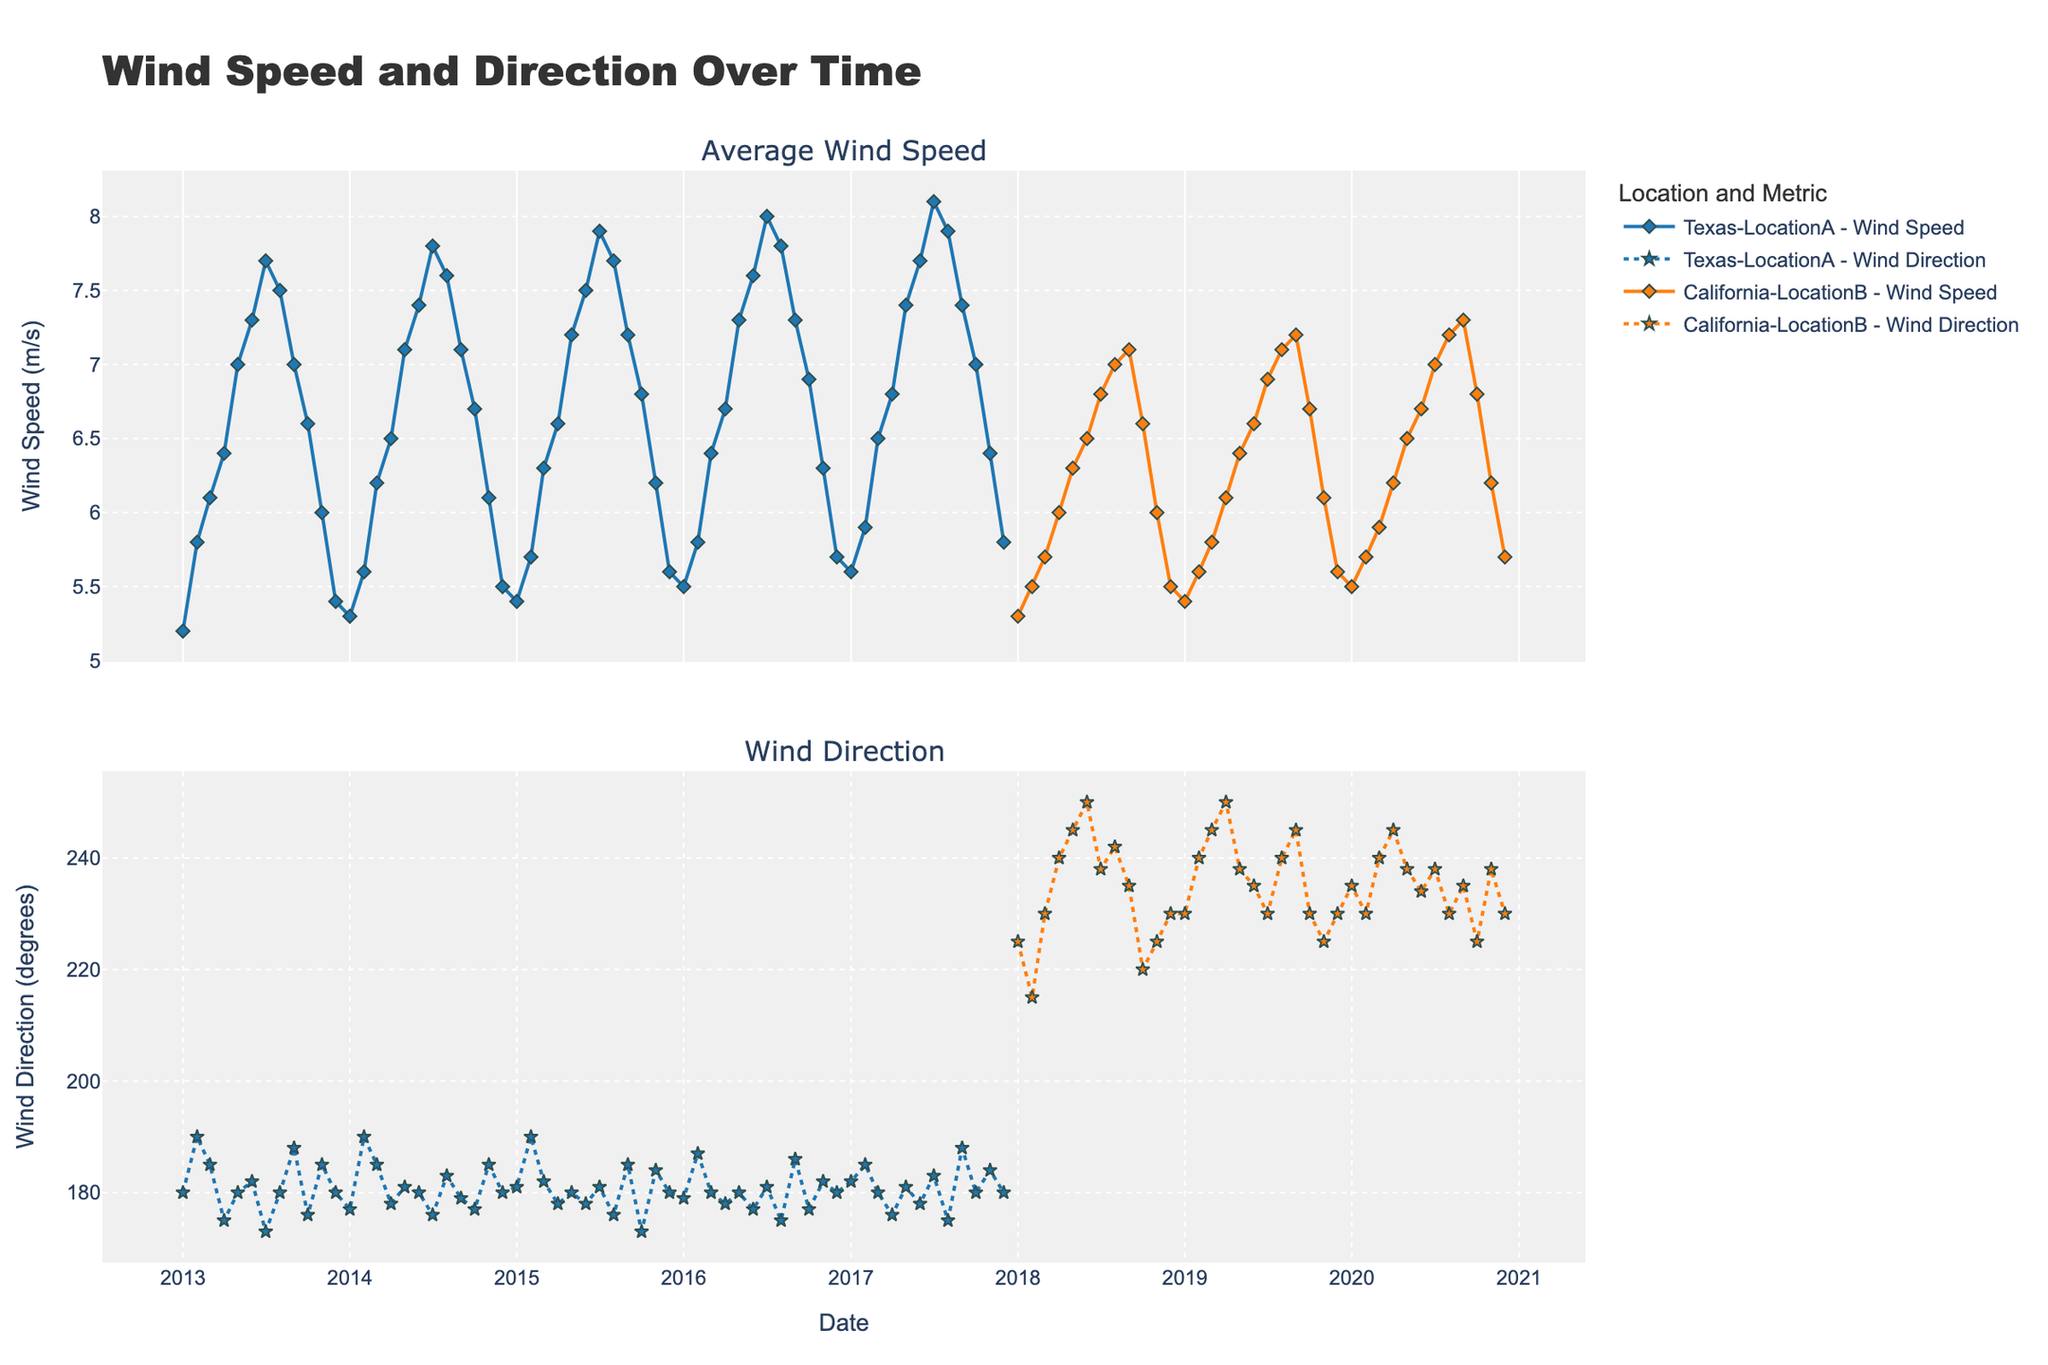What's the title of the plot? The title is located at the top of the plot and summarizes the content of the figure.
Answer: "Wind Speed and Direction Over Time" What are the two subplots in the figure representing? The subplot titles indicate what each subplot represents. The first subplot shows the "Average Wind Speed" and the second subplot shows "Wind Direction".
Answer: "Average Wind Speed" and "Wind Direction" How does the average wind speed in Texas-LocationA generally trend over the years? Observing the line plot for Texas-LocationA in the first subplot, the average wind speed shows an increasing trend with seasonal variations each year but generally increases over time.
Answer: Increasing trend Which location, Texas-LocationA or California-LocationB, shows higher average wind speeds from 2017 to 2020? From the subplot "Average Wind Speed", comparing the lines for each location during 2017-2020, California-LocationB has consistently lower average wind speeds than Texas-LocationA.
Answer: Texas-LocationA What was the average wind speed in Texas-LocationA in July 2017? Locate the data point for July 2017 in the subplot "Average Wind Speed" for Texas-LocationA and read off the value.
Answer: 8.1 m/s Is there any noticeable pattern in wind direction for California-LocationB throughout the year? By looking at the dotted line in the second subplot, for California-LocationB, wind direction generally ranges roughly between 220 and 250 degrees, with slight seasonal variations.
Answer: Yes, between 220 and 250 degrees Compare the wind direction in Texas-LocationA and California-LocationB for January 2018. Which location has a higher value? Locate January 2018 in the second subplot for both locations. Texas-LocationA shows around 182 degrees, while California-LocationB shows about 225 degrees.
Answer: California-LocationB During which month and year did Texas-LocationA have the highest average wind speed, and what was the value? Look through the first subplot, identifying the highest peak for Texas-LocationA and reading off the corresponding date and value.
Answer: July 2017, 8.1 m/s What is the average wind speed over the decade for California-LocationB? Sum the average wind speeds for each month from 2018 to 2020 in the first subplot and divide by the number of data points to find the average.
Answer: 6.3 m/s 